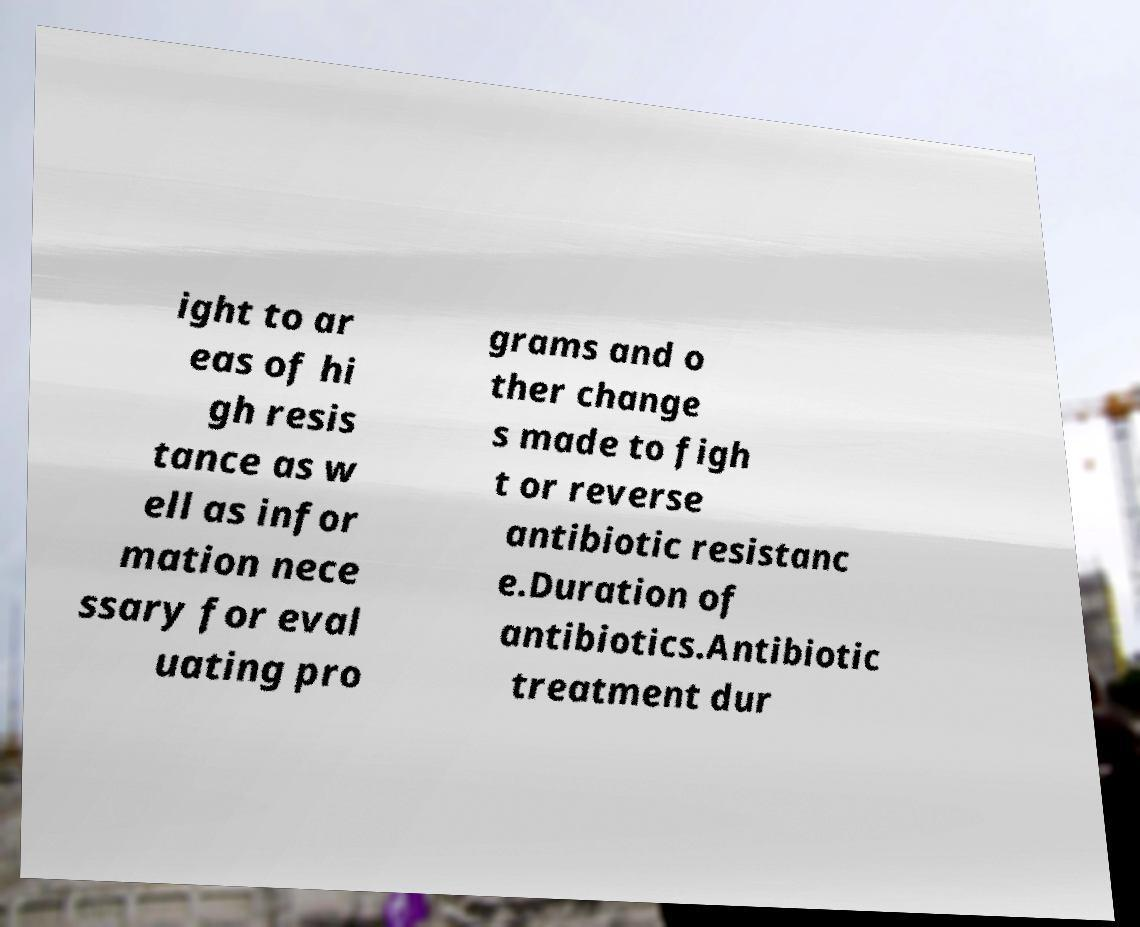There's text embedded in this image that I need extracted. Can you transcribe it verbatim? ight to ar eas of hi gh resis tance as w ell as infor mation nece ssary for eval uating pro grams and o ther change s made to figh t or reverse antibiotic resistanc e.Duration of antibiotics.Antibiotic treatment dur 